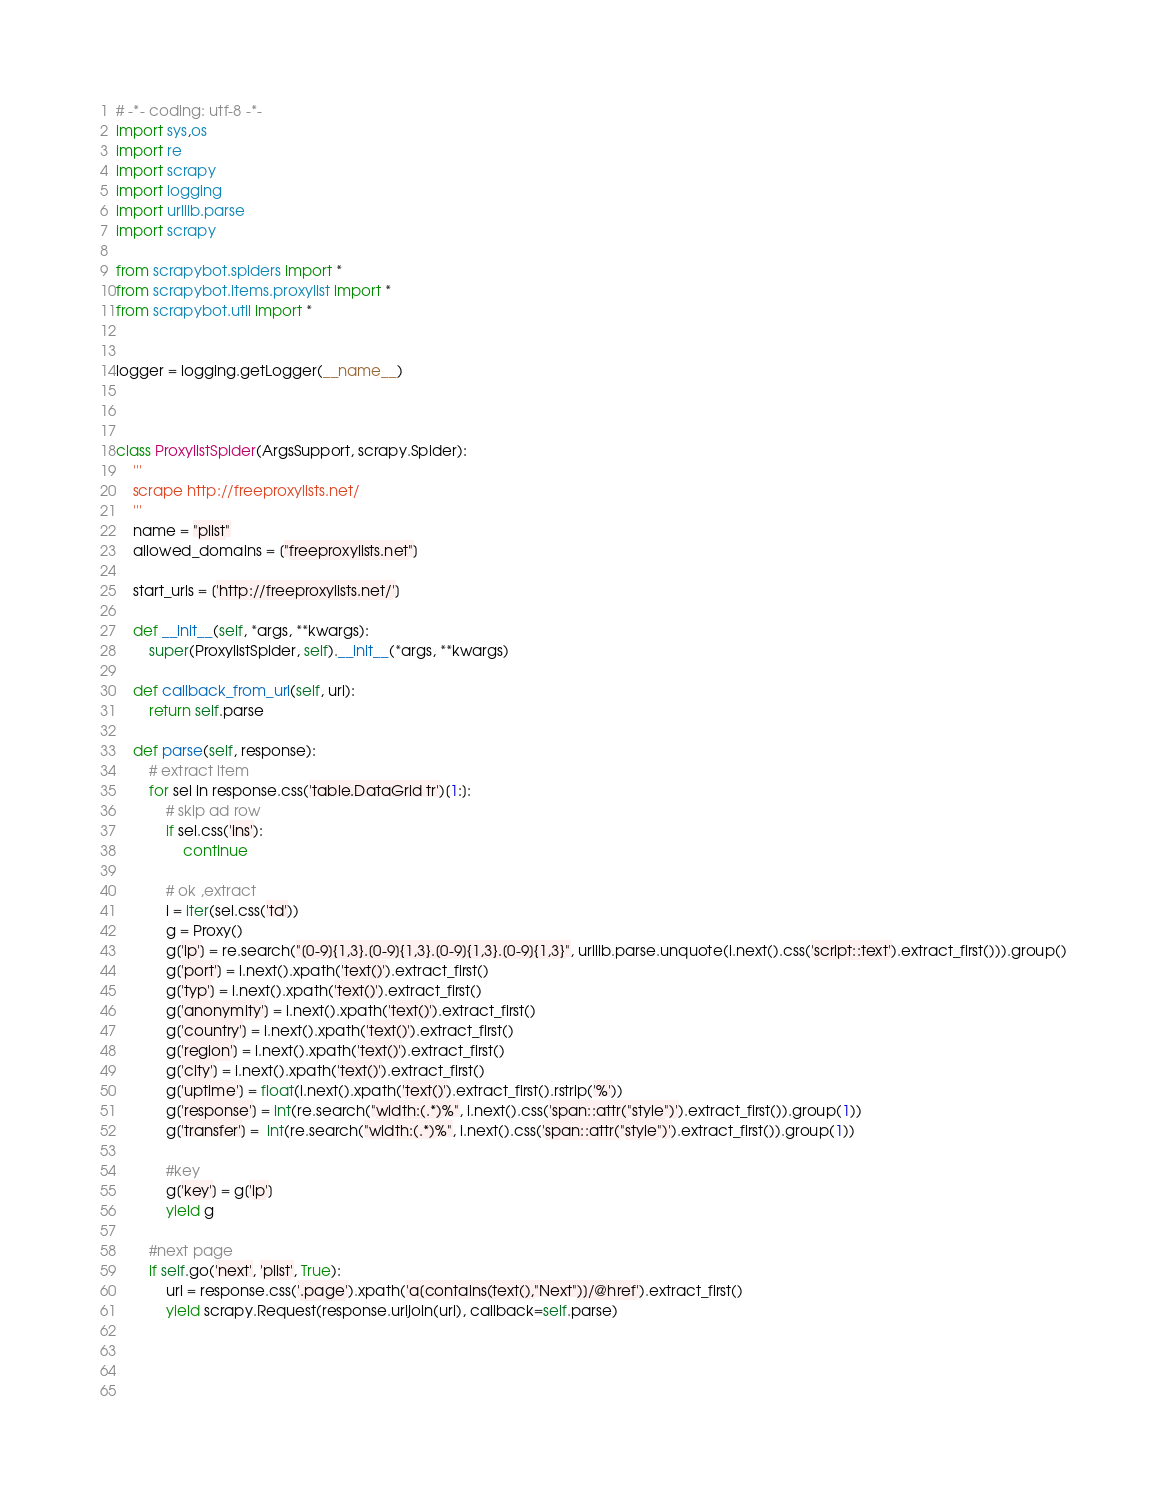Convert code to text. <code><loc_0><loc_0><loc_500><loc_500><_Python_># -*- coding: utf-8 -*-
import sys,os
import re
import scrapy
import logging
import urllib.parse
import scrapy

from scrapybot.spiders import *
from scrapybot.items.proxylist import *
from scrapybot.util import *


logger = logging.getLogger(__name__)



class ProxylistSpider(ArgsSupport, scrapy.Spider):
    '''
    scrape http://freeproxylists.net/
    '''
    name = "plist"
    allowed_domains = ["freeproxylists.net"]

    start_urls = ['http://freeproxylists.net/']

    def __init__(self, *args, **kwargs):
        super(ProxylistSpider, self).__init__(*args, **kwargs)

    def callback_from_url(self, url):
        return self.parse

    def parse(self, response):
        # extract item
        for sel in response.css('table.DataGrid tr')[1:]:
            # skip ad row 
            if sel.css('ins'):
                continue

            # ok ,extract
            i = iter(sel.css('td'))
            g = Proxy()
            g['ip'] = re.search("[0-9]{1,3}.[0-9]{1,3}.[0-9]{1,3}.[0-9]{1,3}", urllib.parse.unquote(i.next().css('script::text').extract_first())).group()
            g['port'] = i.next().xpath('text()').extract_first()
            g['typ'] = i.next().xpath('text()').extract_first()
            g['anonymity'] = i.next().xpath('text()').extract_first()
            g['country'] = i.next().xpath('text()').extract_first()
            g['region'] = i.next().xpath('text()').extract_first()
            g['city'] = i.next().xpath('text()').extract_first()
            g['uptime'] = float(i.next().xpath('text()').extract_first().rstrip('%'))
            g['response'] = int(re.search("width:(.*)%", i.next().css('span::attr("style")').extract_first()).group(1))
            g['transfer'] =  int(re.search("width:(.*)%", i.next().css('span::attr("style")').extract_first()).group(1))

            #key
            g['key'] = g['ip']
            yield g

        #next page
        if self.go('next', 'plist', True):
            url = response.css('.page').xpath('a[contains(text(),"Next")]/@href').extract_first()
            yield scrapy.Request(response.urljoin(url), callback=self.parse)


            
        </code> 